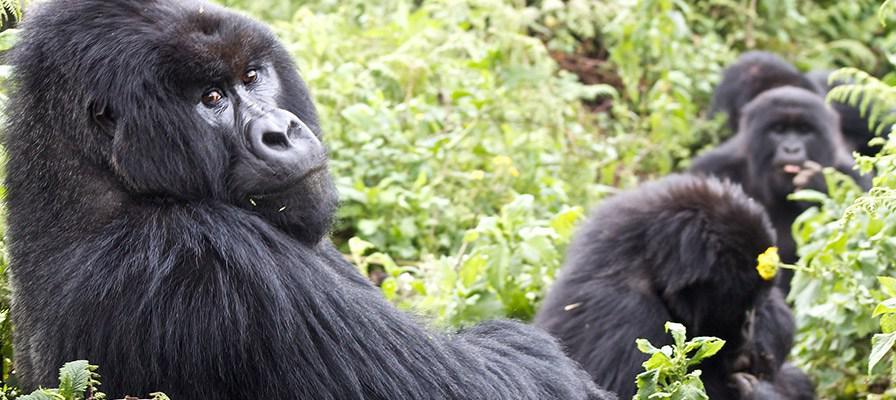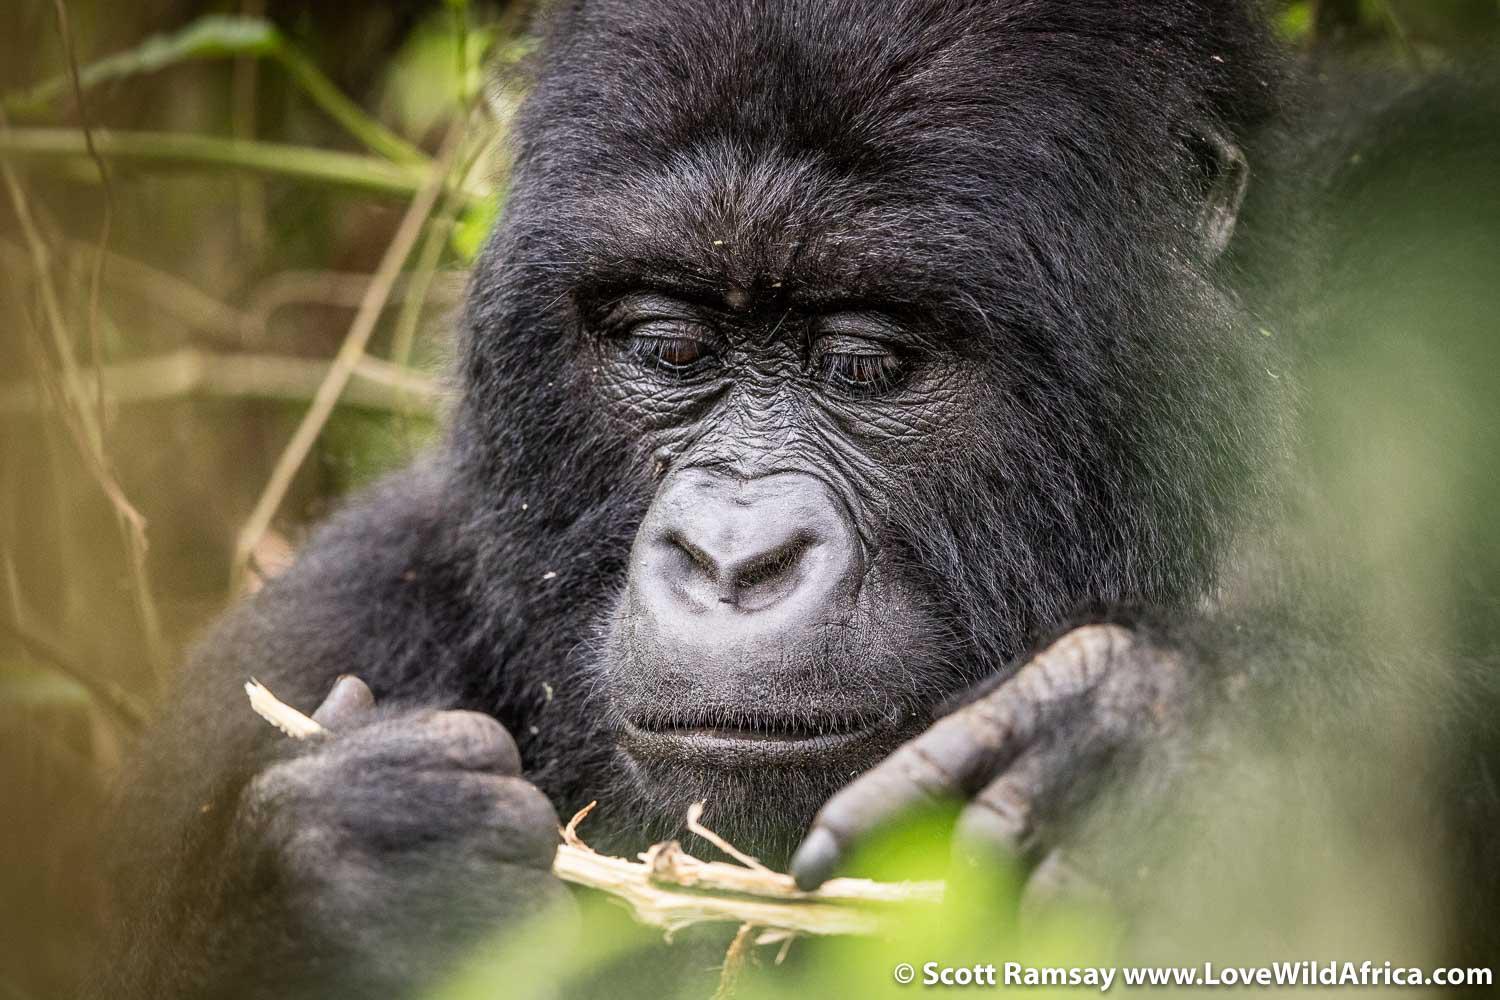The first image is the image on the left, the second image is the image on the right. Given the left and right images, does the statement "The combined images include exactly two baby gorillas with fuzzy black fur and at least one adult." hold true? Answer yes or no. No. The first image is the image on the left, the second image is the image on the right. Considering the images on both sides, is "the left and right image contains the same number of gorillas." valid? Answer yes or no. No. 